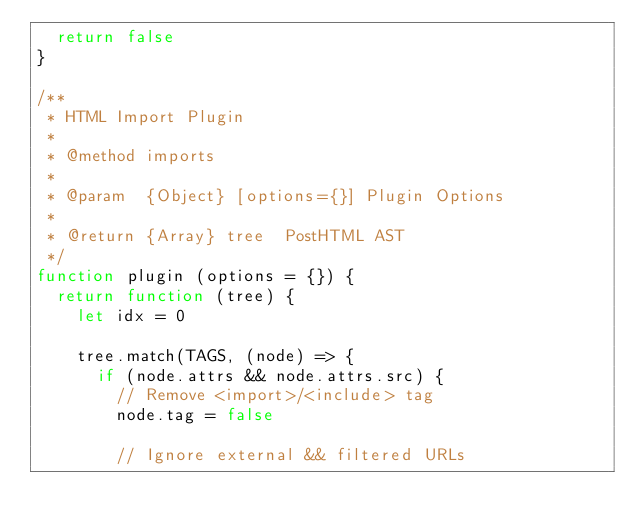Convert code to text. <code><loc_0><loc_0><loc_500><loc_500><_JavaScript_>  return false
}

/**
 * HTML Import Plugin
 *
 * @method imports
 *
 * @param  {Object} [options={}] Plugin Options
 *
 * @return {Array} tree  PostHTML AST
 */
function plugin (options = {}) {
  return function (tree) {
    let idx = 0

    tree.match(TAGS, (node) => {
      if (node.attrs && node.attrs.src) {
        // Remove <import>/<include> tag
        node.tag = false

        // Ignore external && filtered URLs</code> 